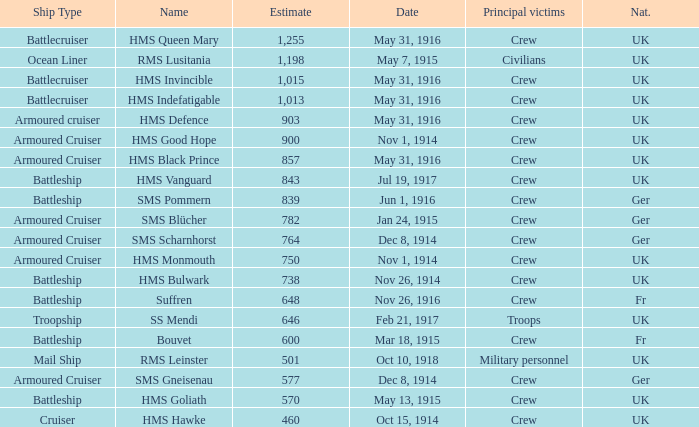What is the name of the battleship with the battle listed on may 13, 1915? HMS Goliath. 